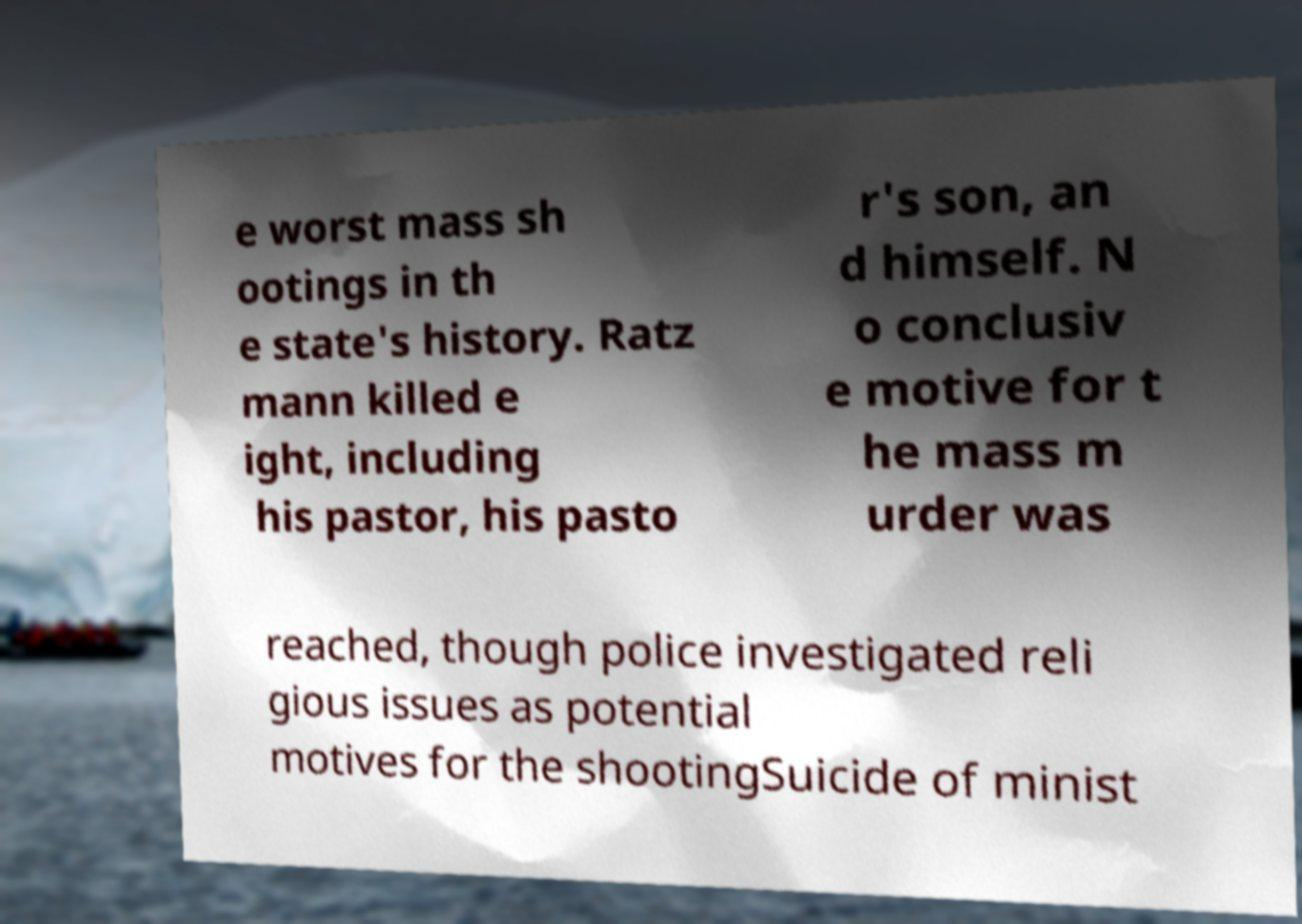I need the written content from this picture converted into text. Can you do that? e worst mass sh ootings in th e state's history. Ratz mann killed e ight, including his pastor, his pasto r's son, an d himself. N o conclusiv e motive for t he mass m urder was reached, though police investigated reli gious issues as potential motives for the shootingSuicide of minist 